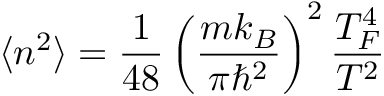<formula> <loc_0><loc_0><loc_500><loc_500>\langle n ^ { 2 } \rangle = \frac { 1 } { 4 8 } \left ( \frac { m k _ { B } } { \pi \hbar { ^ } { 2 } } \right ) ^ { 2 } \frac { T _ { F } ^ { 4 } } { T ^ { 2 } }</formula> 